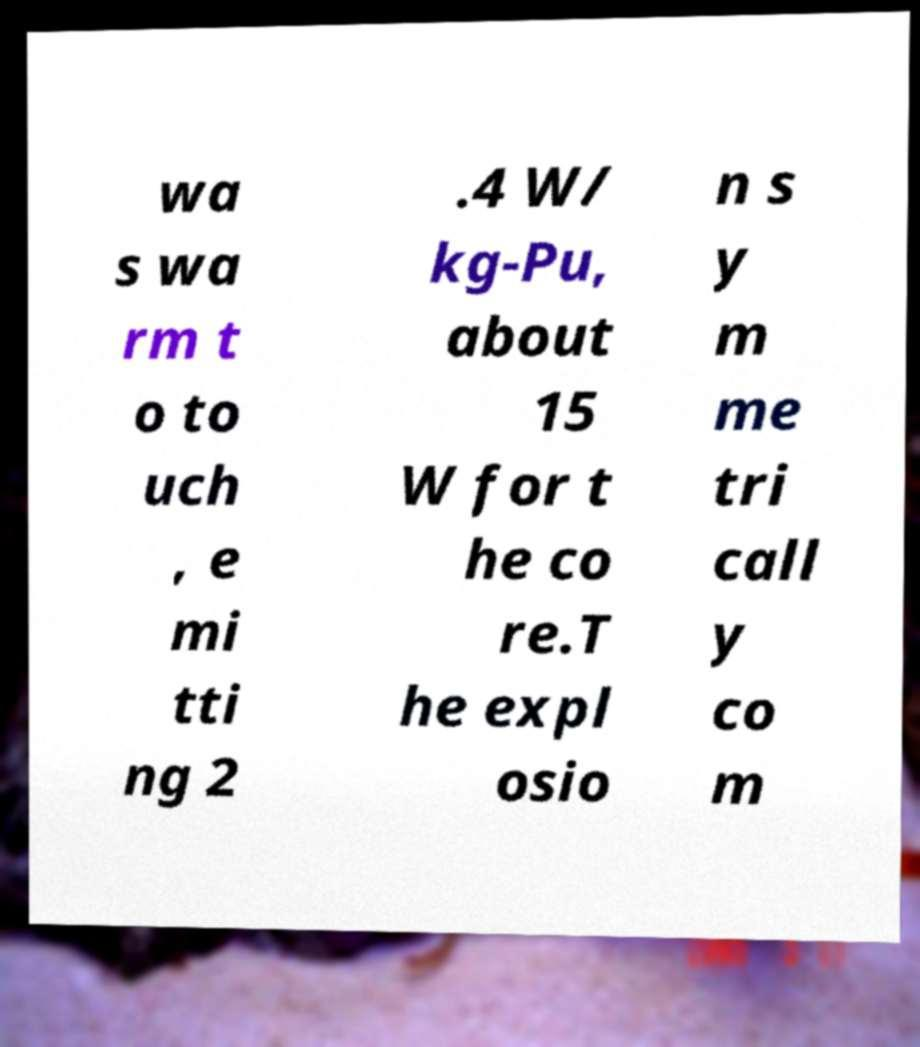Please identify and transcribe the text found in this image. wa s wa rm t o to uch , e mi tti ng 2 .4 W/ kg-Pu, about 15 W for t he co re.T he expl osio n s y m me tri call y co m 